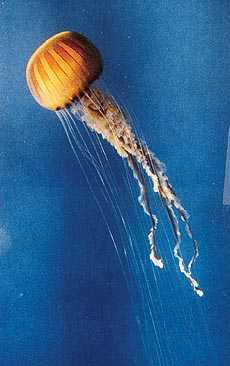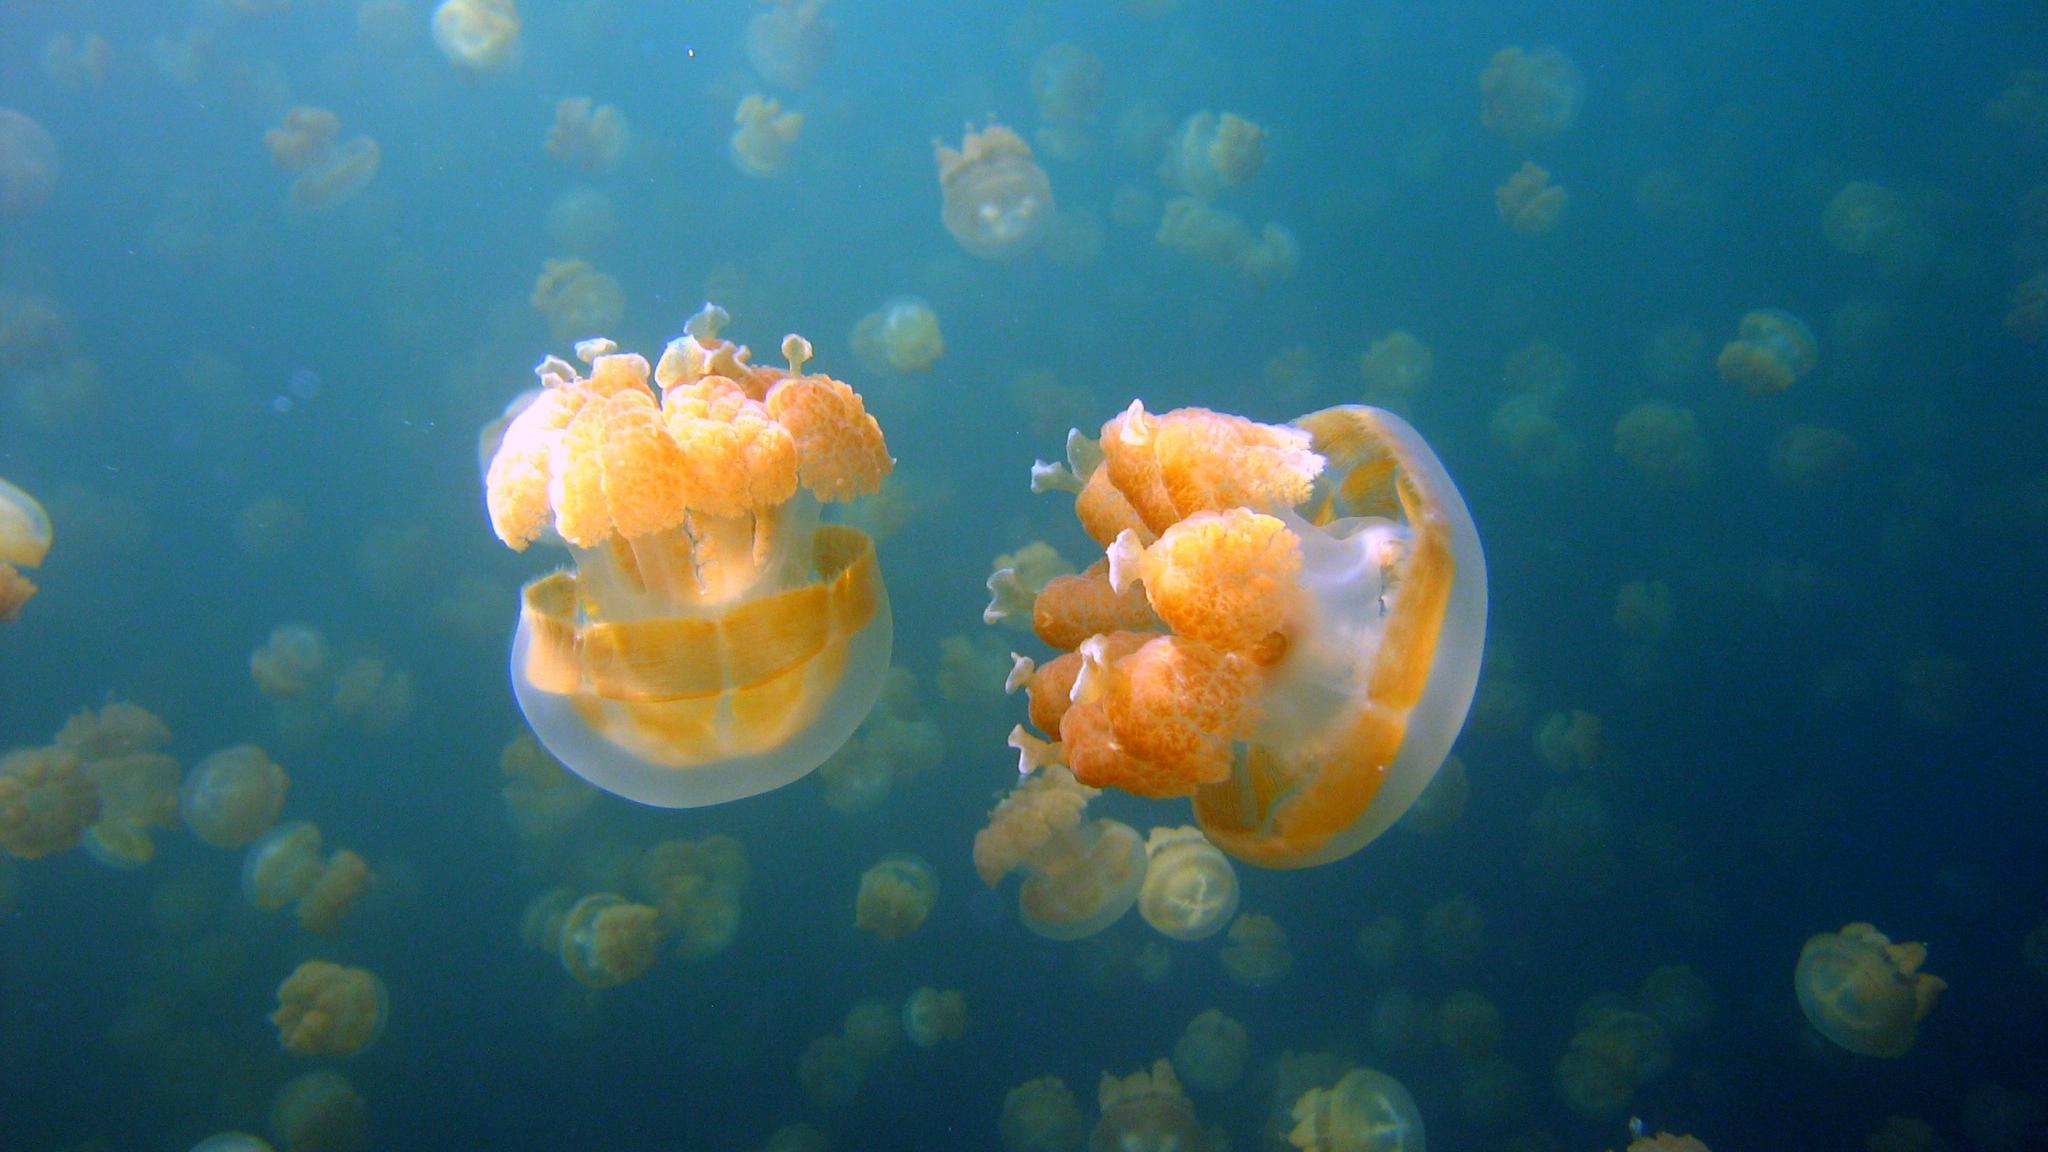The first image is the image on the left, the second image is the image on the right. For the images shown, is this caption "One image shows a single upside-down beige jellyfish with short tentacles extending upward from a saucer-shaped 'cap', and the other image shows a glowing yellowish jellyfish with long stringy tentacles trailing down from a dome 'cap'." true? Answer yes or no. No. The first image is the image on the left, the second image is the image on the right. Evaluate the accuracy of this statement regarding the images: "One organism is on the bottom.". Is it true? Answer yes or no. No. 